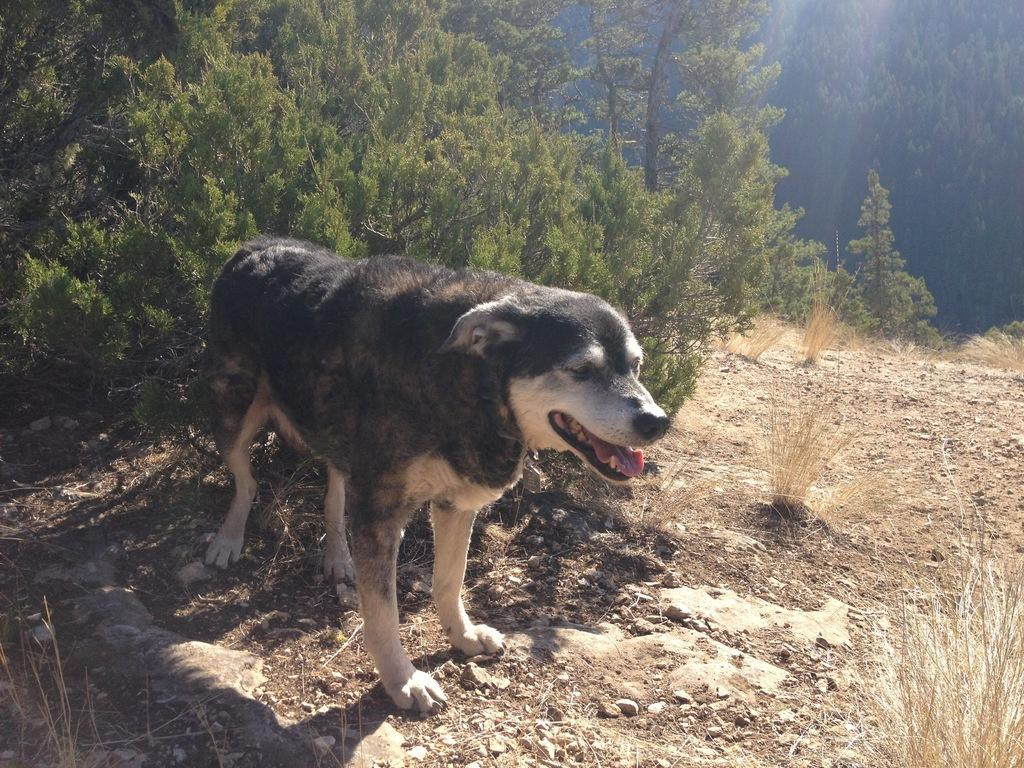What animal can be seen in the image? There is a dog standing in the image. What type of terrain is visible in the image? Soil, rocks, and trees can be seen in the image. Can you describe the vegetation in the image? There are trees in the image. How many eyes does the dog have in the image? The number of eyes cannot be determined from the image, as it only shows the dog's body and not its face. 